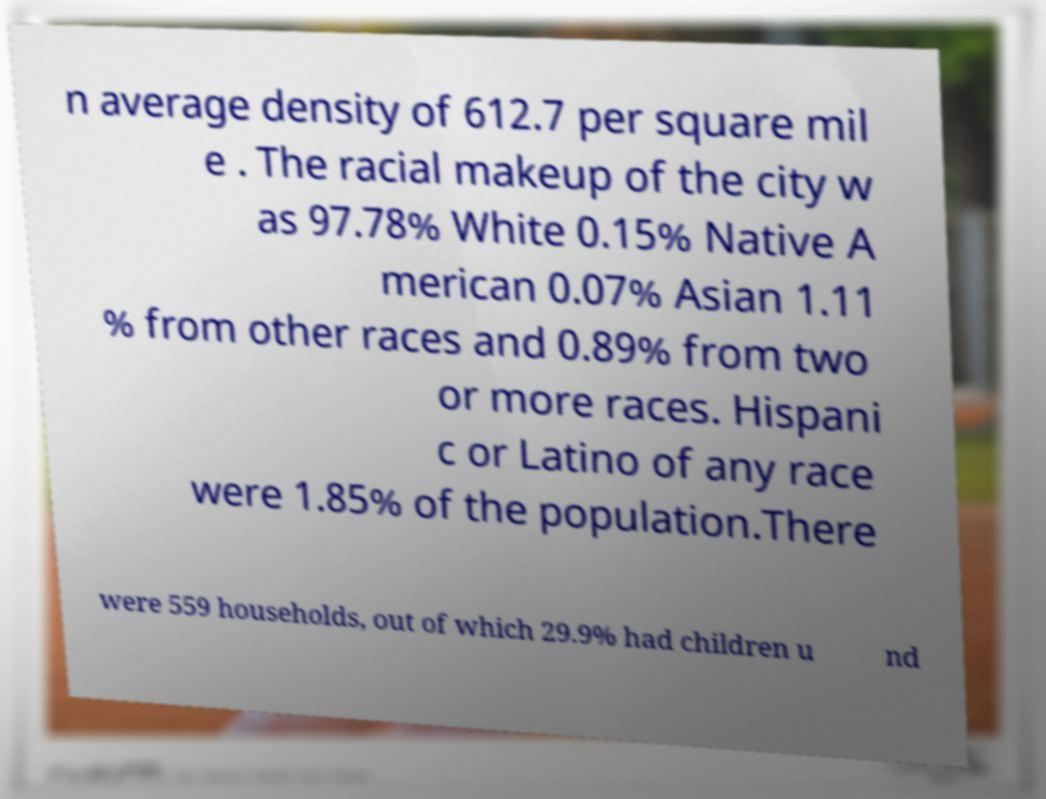Please identify and transcribe the text found in this image. n average density of 612.7 per square mil e . The racial makeup of the city w as 97.78% White 0.15% Native A merican 0.07% Asian 1.11 % from other races and 0.89% from two or more races. Hispani c or Latino of any race were 1.85% of the population.There were 559 households, out of which 29.9% had children u nd 